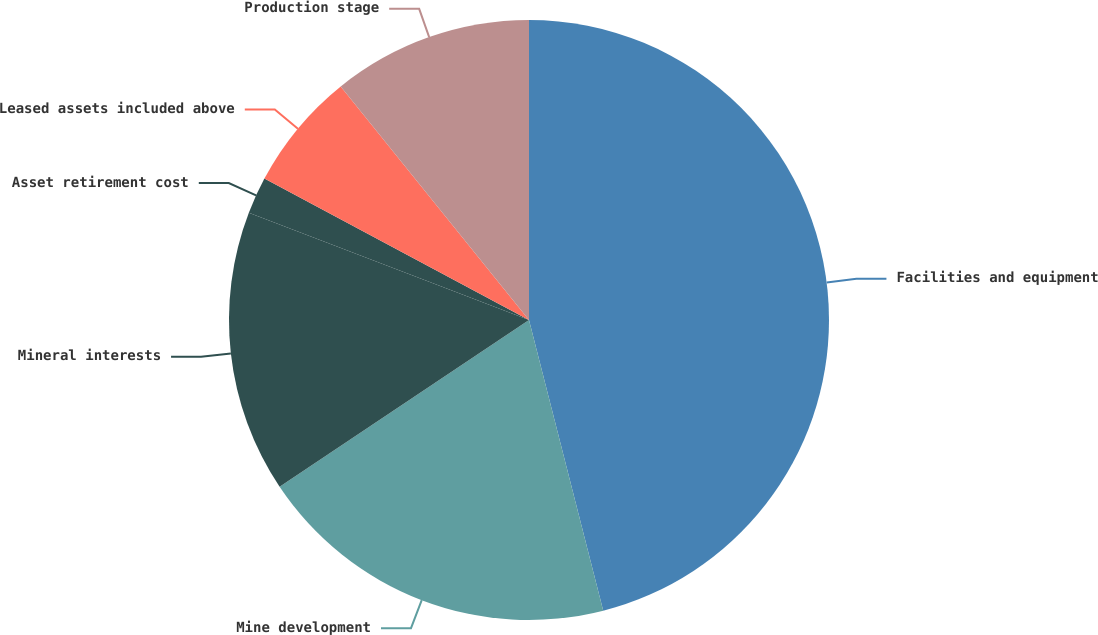<chart> <loc_0><loc_0><loc_500><loc_500><pie_chart><fcel>Facilities and equipment<fcel>Mine development<fcel>Mineral interests<fcel>Asset retirement cost<fcel>Leased assets included above<fcel>Production stage<nl><fcel>46.02%<fcel>19.6%<fcel>15.2%<fcel>1.99%<fcel>6.39%<fcel>10.8%<nl></chart> 